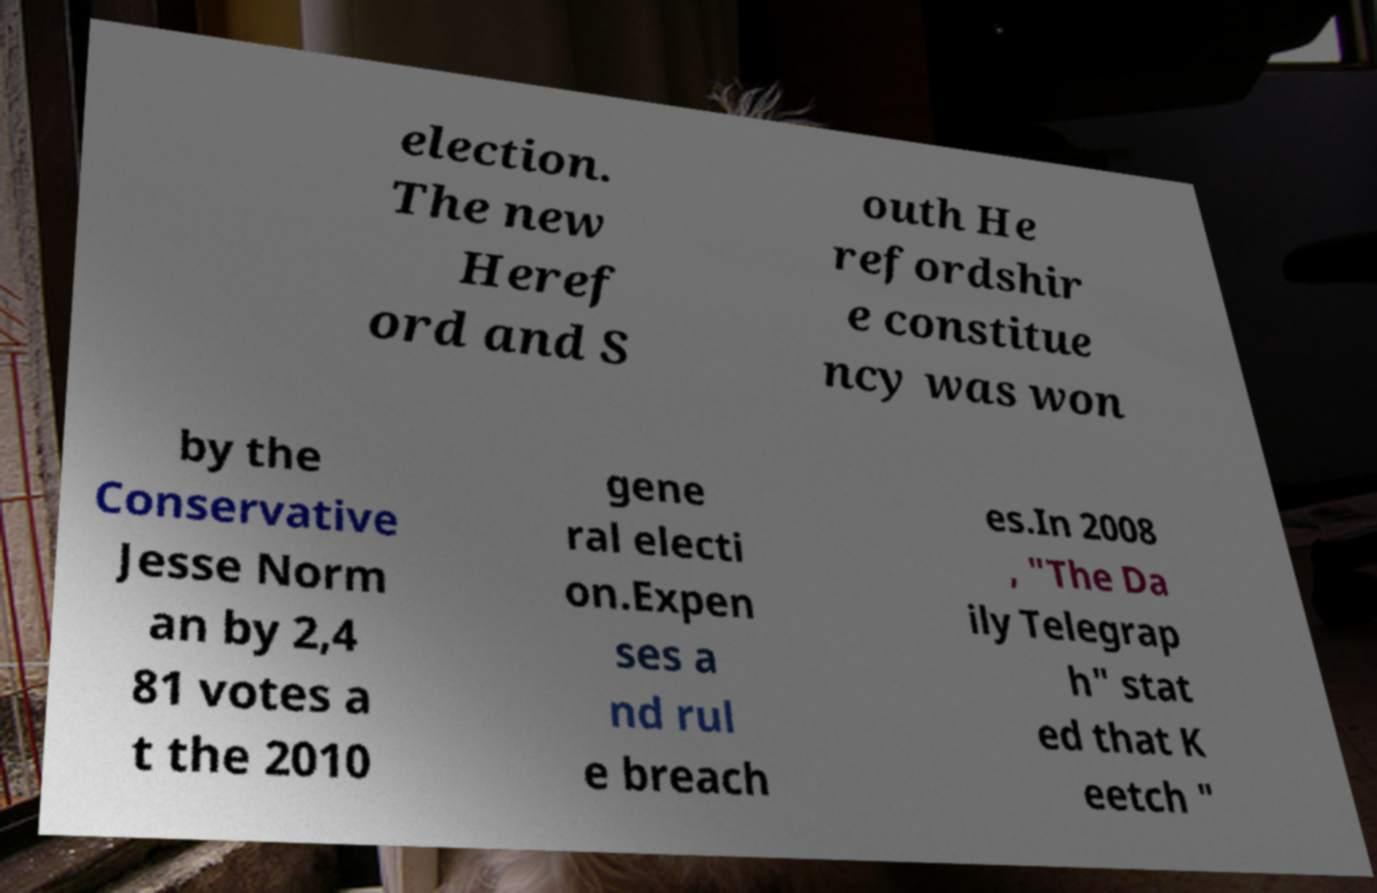Can you accurately transcribe the text from the provided image for me? election. The new Heref ord and S outh He refordshir e constitue ncy was won by the Conservative Jesse Norm an by 2,4 81 votes a t the 2010 gene ral electi on.Expen ses a nd rul e breach es.In 2008 , "The Da ily Telegrap h" stat ed that K eetch " 